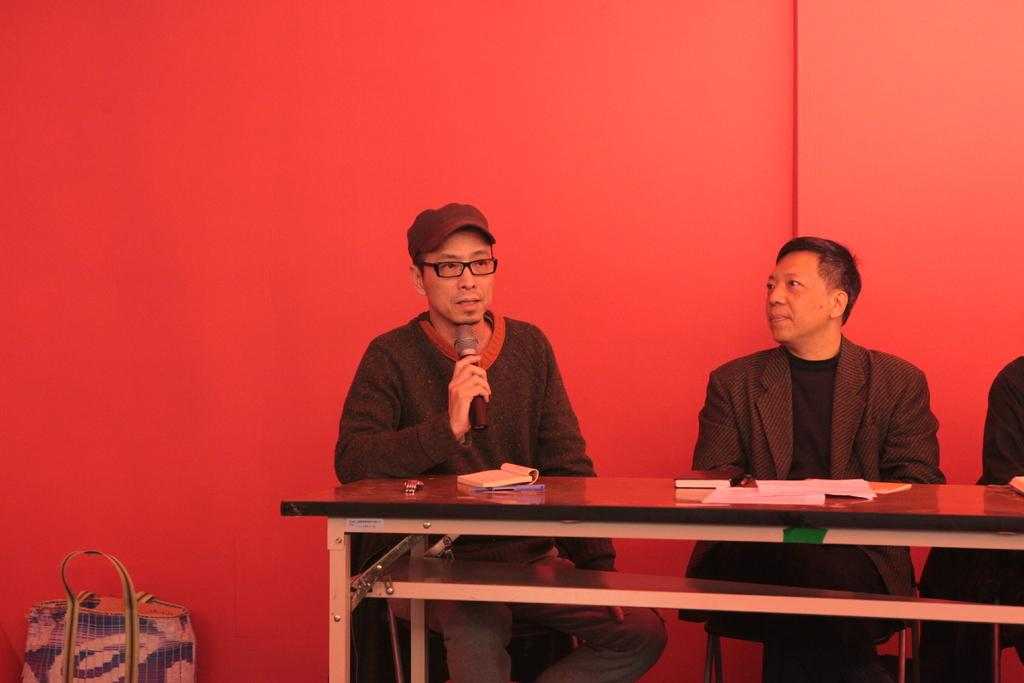How many people are in the image? There are two people in the image. What are the people doing in the image? The people are sitting on chairs. What is in front of the chairs? There is a desk in front of the chairs. What items can be seen on the desk? There are papers, a diary, a watch, and a pen on the desk. What object is to the left side of the desk? There is a bag to the left side of the desk. What type of appliance is visible on the desk in the image? There is no appliance visible on the desk in the image. What color is the sky in the image? The sky is not visible in the image, so its color cannot be determined. 